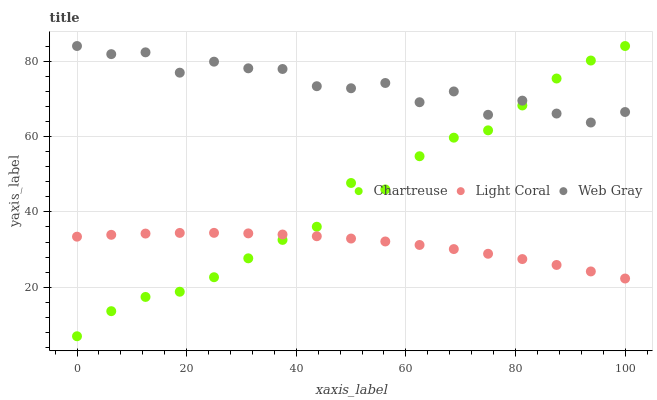Does Light Coral have the minimum area under the curve?
Answer yes or no. Yes. Does Web Gray have the maximum area under the curve?
Answer yes or no. Yes. Does Chartreuse have the minimum area under the curve?
Answer yes or no. No. Does Chartreuse have the maximum area under the curve?
Answer yes or no. No. Is Light Coral the smoothest?
Answer yes or no. Yes. Is Web Gray the roughest?
Answer yes or no. Yes. Is Chartreuse the smoothest?
Answer yes or no. No. Is Chartreuse the roughest?
Answer yes or no. No. Does Chartreuse have the lowest value?
Answer yes or no. Yes. Does Web Gray have the lowest value?
Answer yes or no. No. Does Web Gray have the highest value?
Answer yes or no. Yes. Is Light Coral less than Web Gray?
Answer yes or no. Yes. Is Web Gray greater than Light Coral?
Answer yes or no. Yes. Does Web Gray intersect Chartreuse?
Answer yes or no. Yes. Is Web Gray less than Chartreuse?
Answer yes or no. No. Is Web Gray greater than Chartreuse?
Answer yes or no. No. Does Light Coral intersect Web Gray?
Answer yes or no. No. 